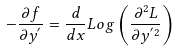<formula> <loc_0><loc_0><loc_500><loc_500>- \frac { \partial f } { \partial y ^ { ^ { \prime } } } = \frac { d } { d x } L o g \left ( \frac { \partial ^ { 2 } L } { \partial y ^ { ^ { \prime } 2 } } \right )</formula> 